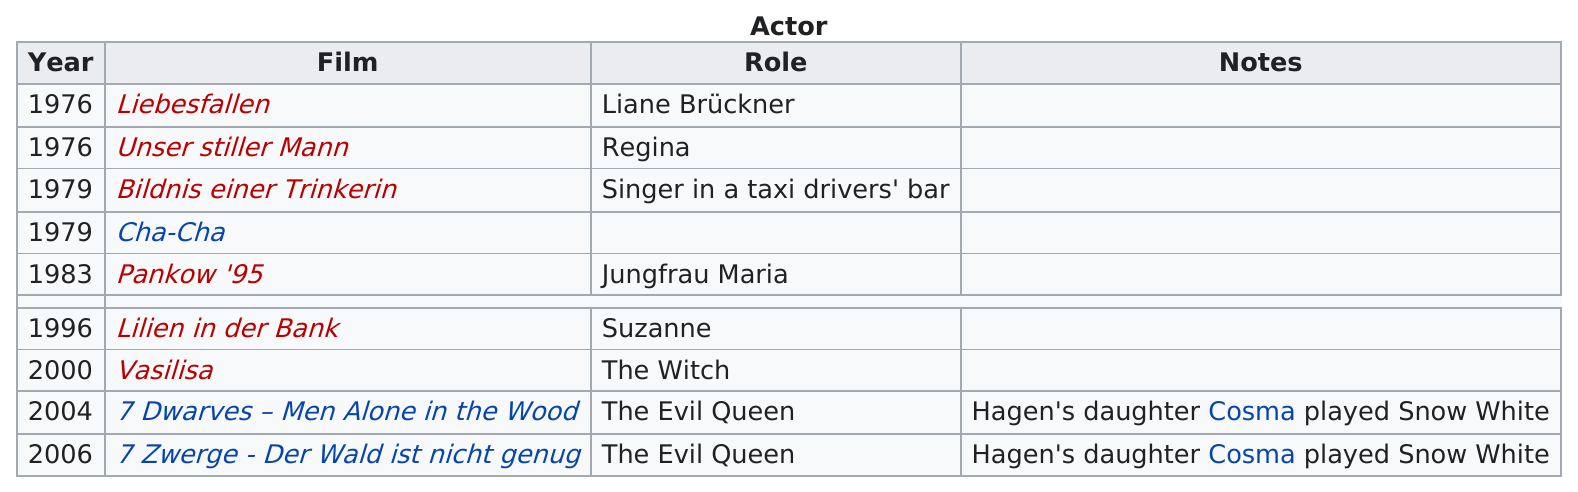Specify some key components in this picture. Nina Hagan performed in the musical "Pankow '95" after "Cha-Cha. The film in which the character named Regina appears is "Unser stiller Mann... The first role on the chart is Liane Brückner. The film that features the character of the evil queen and was released in 2004 is '7 Dwarves - Men Alone in the Woods.' Nina Hagan was the Evil Queen on two occasions. 